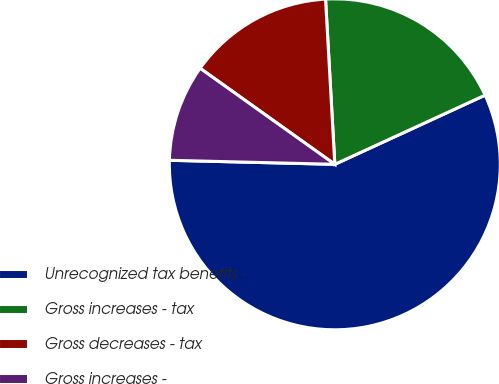Convert chart. <chart><loc_0><loc_0><loc_500><loc_500><pie_chart><fcel>Unrecognized tax benefits -<fcel>Gross increases - tax<fcel>Gross decreases - tax<fcel>Gross increases -<nl><fcel>57.26%<fcel>19.03%<fcel>14.25%<fcel>9.47%<nl></chart> 